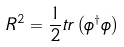Convert formula to latex. <formula><loc_0><loc_0><loc_500><loc_500>R ^ { 2 } = \frac { 1 } { 2 } t r \left ( \phi ^ { \dagger } \phi \right )</formula> 